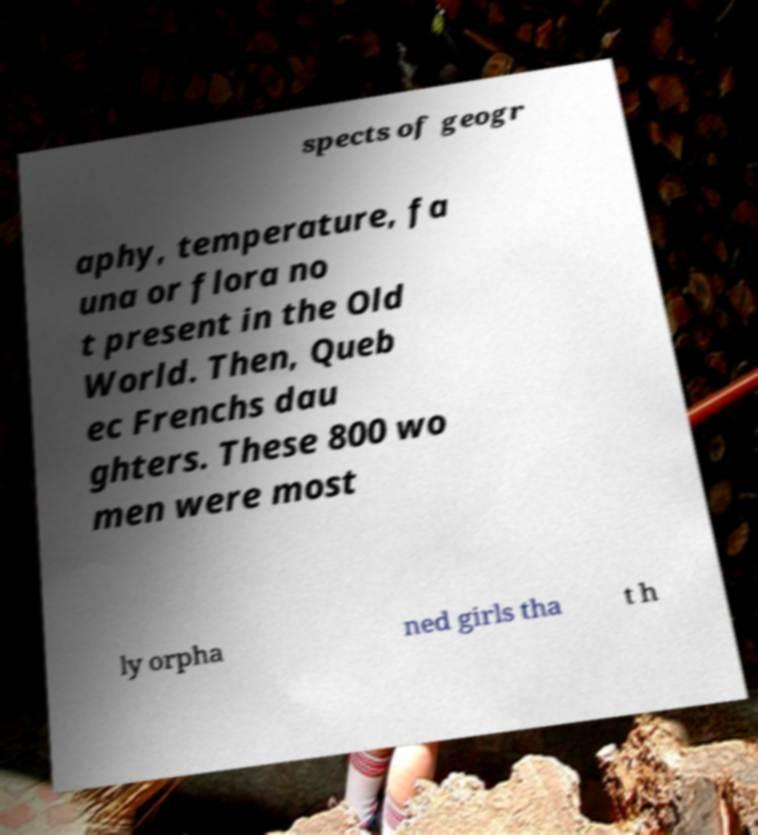Please read and relay the text visible in this image. What does it say? spects of geogr aphy, temperature, fa una or flora no t present in the Old World. Then, Queb ec Frenchs dau ghters. These 800 wo men were most ly orpha ned girls tha t h 